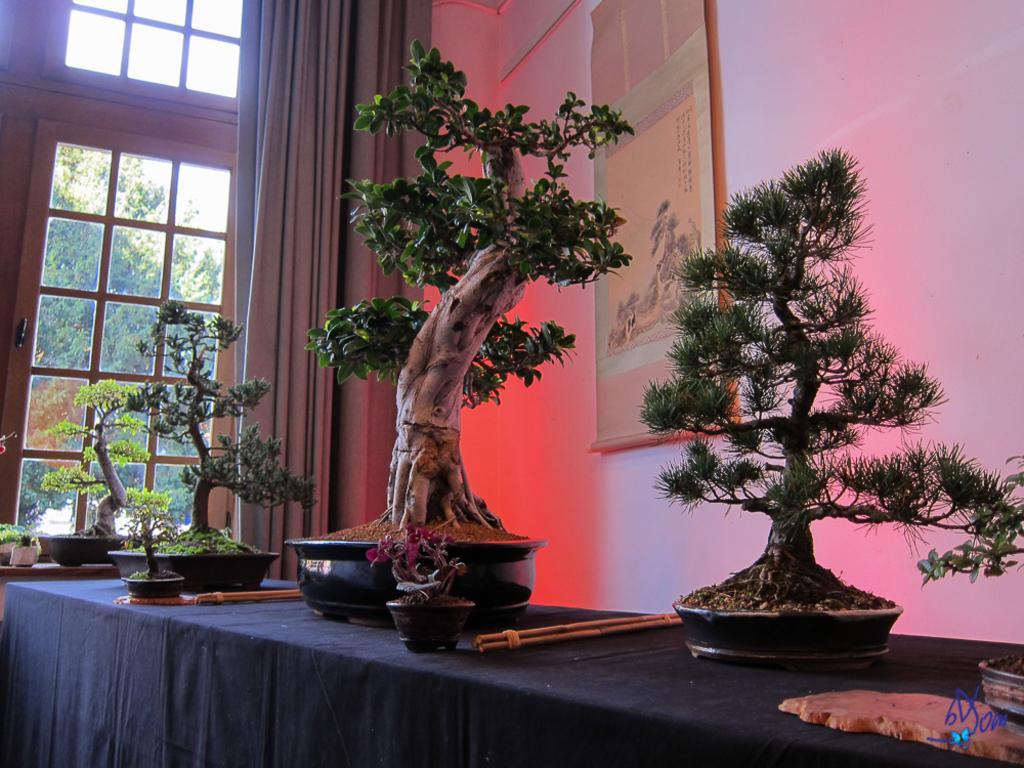In one or two sentences, can you explain what this image depicts? In the image I can see trees, plant pots, a black cloth and some other objects on the table. In the background I can see wall which has some object attached to it, curtains, framed glass wall and trees. 